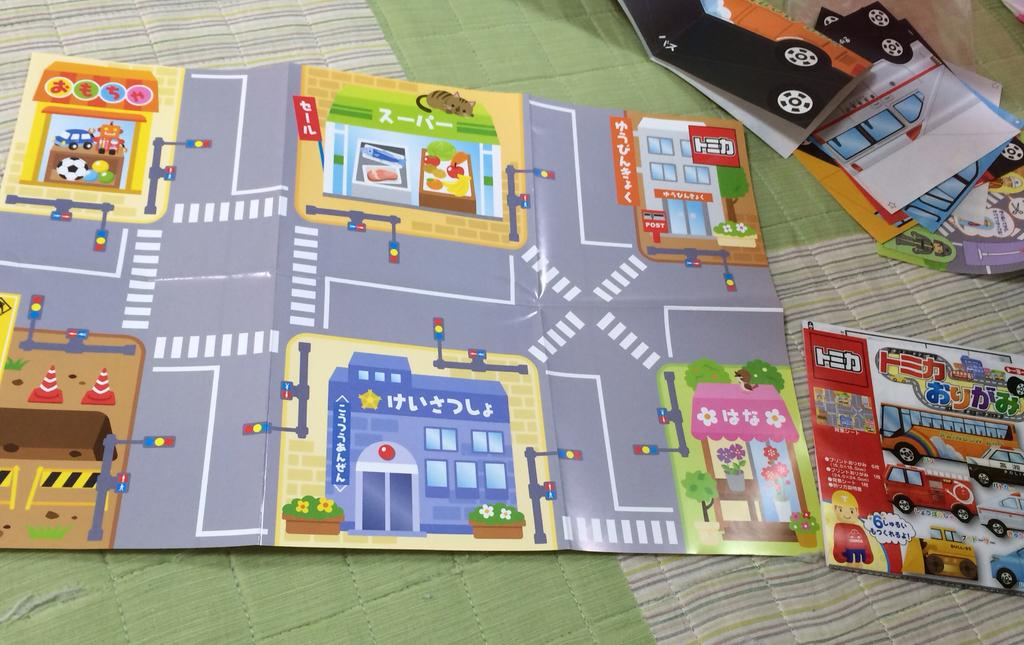What type of objects are on the surface in the image? There are game cards on a surface in the image. Are there any other objects present on the same surface? Yes, there is at least one other object on the same surface in the image. How does the wind affect the game cards in the image? There is no indication of wind in the image, and therefore its effect on the game cards cannot be determined. 